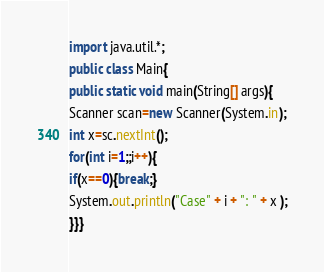Convert code to text. <code><loc_0><loc_0><loc_500><loc_500><_Java_>import java.util.*;
public class Main{
public static void main(String[] args){
Scanner scan=new Scanner(System.in);
int x=sc.nextInt();
for(int i=1;;i++){
if(x==0){break;}
System.out.println("Case" + i + ": " + x );
}}}</code> 